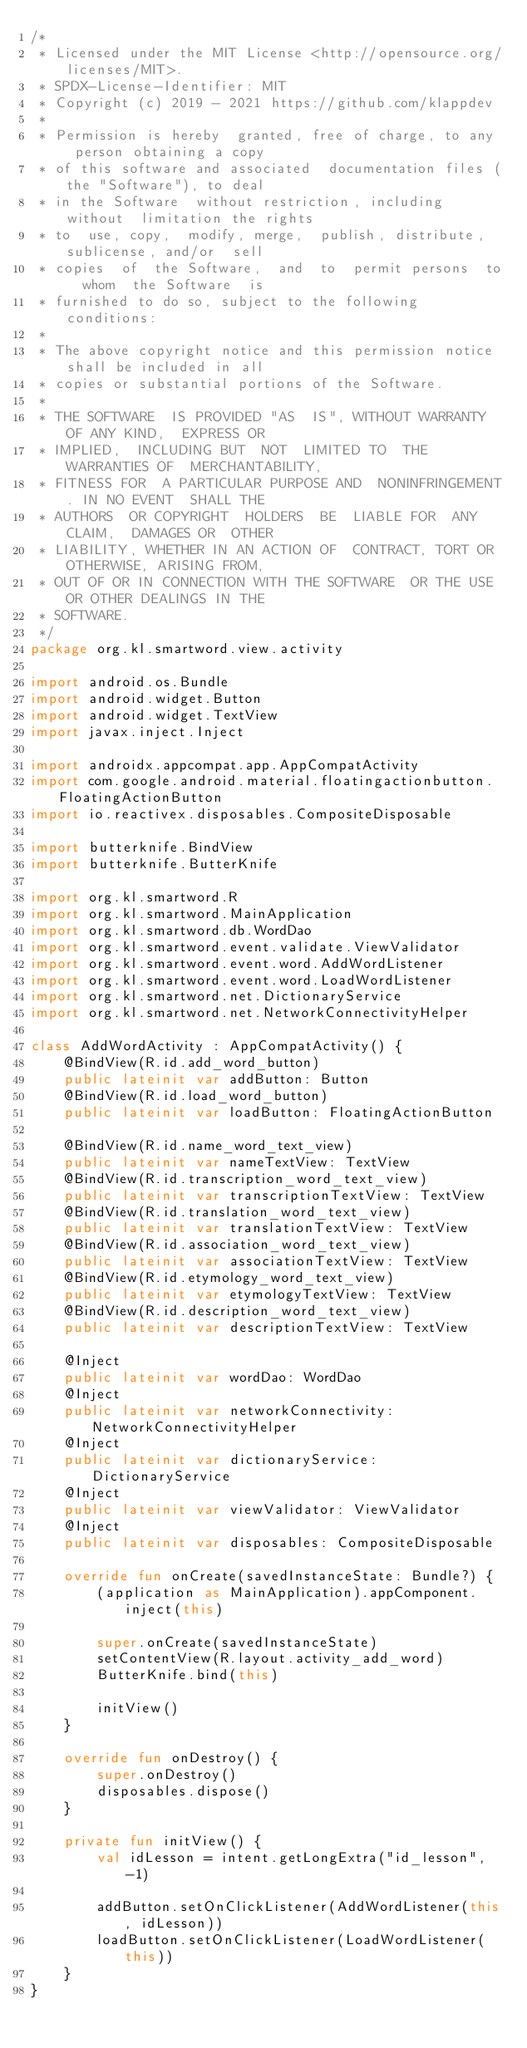Convert code to text. <code><loc_0><loc_0><loc_500><loc_500><_Kotlin_>/*
 * Licensed under the MIT License <http://opensource.org/licenses/MIT>.
 * SPDX-License-Identifier: MIT
 * Copyright (c) 2019 - 2021 https://github.com/klappdev
 *
 * Permission is hereby  granted, free of charge, to any  person obtaining a copy
 * of this software and associated  documentation files (the "Software"), to deal
 * in the Software  without restriction, including without  limitation the rights
 * to  use, copy,  modify, merge,  publish, distribute,  sublicense, and/or  sell
 * copies  of  the Software,  and  to  permit persons  to  whom  the Software  is
 * furnished to do so, subject to the following conditions:
 *
 * The above copyright notice and this permission notice shall be included in all
 * copies or substantial portions of the Software.
 *
 * THE SOFTWARE  IS PROVIDED "AS  IS", WITHOUT WARRANTY  OF ANY KIND,  EXPRESS OR
 * IMPLIED,  INCLUDING BUT  NOT  LIMITED TO  THE  WARRANTIES OF  MERCHANTABILITY,
 * FITNESS FOR  A PARTICULAR PURPOSE AND  NONINFRINGEMENT. IN NO EVENT  SHALL THE
 * AUTHORS  OR COPYRIGHT  HOLDERS  BE  LIABLE FOR  ANY  CLAIM,  DAMAGES OR  OTHER
 * LIABILITY, WHETHER IN AN ACTION OF  CONTRACT, TORT OR OTHERWISE, ARISING FROM,
 * OUT OF OR IN CONNECTION WITH THE SOFTWARE  OR THE USE OR OTHER DEALINGS IN THE
 * SOFTWARE.
 */
package org.kl.smartword.view.activity

import android.os.Bundle
import android.widget.Button
import android.widget.TextView
import javax.inject.Inject

import androidx.appcompat.app.AppCompatActivity
import com.google.android.material.floatingactionbutton.FloatingActionButton
import io.reactivex.disposables.CompositeDisposable

import butterknife.BindView
import butterknife.ButterKnife

import org.kl.smartword.R
import org.kl.smartword.MainApplication
import org.kl.smartword.db.WordDao
import org.kl.smartword.event.validate.ViewValidator
import org.kl.smartword.event.word.AddWordListener
import org.kl.smartword.event.word.LoadWordListener
import org.kl.smartword.net.DictionaryService
import org.kl.smartword.net.NetworkConnectivityHelper

class AddWordActivity : AppCompatActivity() {
    @BindView(R.id.add_word_button)
    public lateinit var addButton: Button
    @BindView(R.id.load_word_button)
    public lateinit var loadButton: FloatingActionButton

    @BindView(R.id.name_word_text_view)
    public lateinit var nameTextView: TextView
    @BindView(R.id.transcription_word_text_view)
    public lateinit var transcriptionTextView: TextView
    @BindView(R.id.translation_word_text_view)
    public lateinit var translationTextView: TextView
    @BindView(R.id.association_word_text_view)
    public lateinit var associationTextView: TextView
    @BindView(R.id.etymology_word_text_view)
    public lateinit var etymologyTextView: TextView
    @BindView(R.id.description_word_text_view)
    public lateinit var descriptionTextView: TextView

    @Inject
    public lateinit var wordDao: WordDao
    @Inject
    public lateinit var networkConnectivity: NetworkConnectivityHelper
    @Inject
    public lateinit var dictionaryService: DictionaryService
    @Inject
    public lateinit var viewValidator: ViewValidator
    @Inject
    public lateinit var disposables: CompositeDisposable

    override fun onCreate(savedInstanceState: Bundle?) {
        (application as MainApplication).appComponent.inject(this)

        super.onCreate(savedInstanceState)
        setContentView(R.layout.activity_add_word)
        ButterKnife.bind(this)

        initView()
    }

    override fun onDestroy() {
        super.onDestroy()
        disposables.dispose()
    }

    private fun initView() {
        val idLesson = intent.getLongExtra("id_lesson", -1)

        addButton.setOnClickListener(AddWordListener(this, idLesson))
        loadButton.setOnClickListener(LoadWordListener(this))
    }
}
</code> 